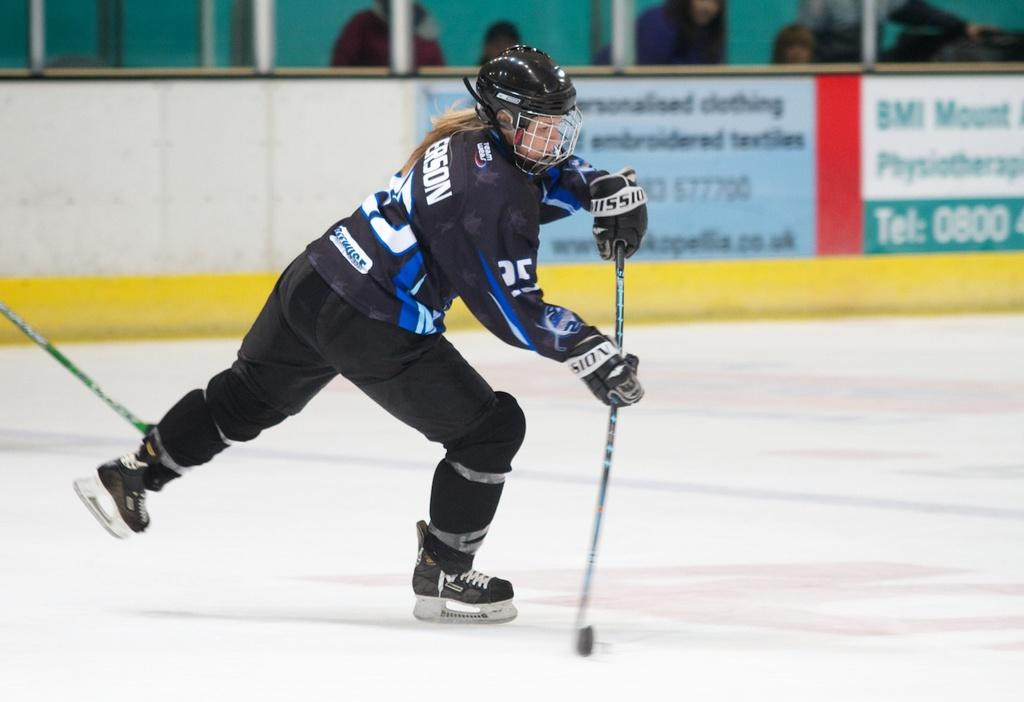Who is the main subject in the image? There is a woman in the image. What is the woman wearing? The woman is wearing a black dress and a helmet. What activity is the woman engaged in? The woman is playing ice hockey. What can be seen in the background of the image? There is a board and people standing in the background of the image. How many beds are visible in the image? There are no beds visible in the image. What does the woman look like while playing ice hockey? The image does not provide a detailed description of the woman's facial expression or body language while playing ice hockey. 